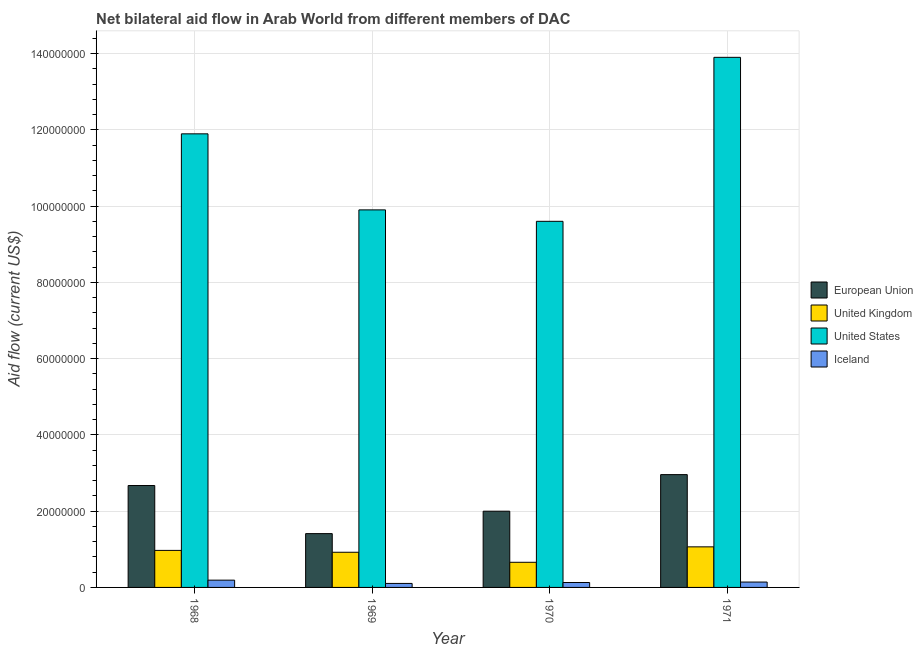How many groups of bars are there?
Provide a short and direct response. 4. Are the number of bars on each tick of the X-axis equal?
Make the answer very short. Yes. How many bars are there on the 2nd tick from the left?
Make the answer very short. 4. How many bars are there on the 1st tick from the right?
Provide a succinct answer. 4. What is the label of the 3rd group of bars from the left?
Your answer should be very brief. 1970. In how many cases, is the number of bars for a given year not equal to the number of legend labels?
Provide a succinct answer. 0. What is the amount of aid given by iceland in 1968?
Give a very brief answer. 1.91e+06. Across all years, what is the maximum amount of aid given by iceland?
Your response must be concise. 1.91e+06. Across all years, what is the minimum amount of aid given by iceland?
Provide a short and direct response. 1.05e+06. In which year was the amount of aid given by eu maximum?
Your answer should be compact. 1971. In which year was the amount of aid given by iceland minimum?
Your answer should be very brief. 1969. What is the total amount of aid given by iceland in the graph?
Provide a succinct answer. 5.66e+06. What is the difference between the amount of aid given by us in 1968 and that in 1970?
Keep it short and to the point. 2.29e+07. What is the difference between the amount of aid given by eu in 1970 and the amount of aid given by uk in 1968?
Keep it short and to the point. -6.73e+06. What is the average amount of aid given by us per year?
Make the answer very short. 1.13e+08. What is the ratio of the amount of aid given by iceland in 1968 to that in 1969?
Ensure brevity in your answer.  1.82. What is the difference between the highest and the second highest amount of aid given by eu?
Provide a succinct answer. 2.86e+06. What is the difference between the highest and the lowest amount of aid given by eu?
Keep it short and to the point. 1.55e+07. In how many years, is the amount of aid given by iceland greater than the average amount of aid given by iceland taken over all years?
Ensure brevity in your answer.  1. What does the 1st bar from the right in 1969 represents?
Keep it short and to the point. Iceland. How many bars are there?
Give a very brief answer. 16. Are all the bars in the graph horizontal?
Offer a very short reply. No. How many years are there in the graph?
Offer a very short reply. 4. What is the difference between two consecutive major ticks on the Y-axis?
Your answer should be very brief. 2.00e+07. Are the values on the major ticks of Y-axis written in scientific E-notation?
Give a very brief answer. No. Does the graph contain grids?
Ensure brevity in your answer.  Yes. Where does the legend appear in the graph?
Provide a succinct answer. Center right. How are the legend labels stacked?
Provide a succinct answer. Vertical. What is the title of the graph?
Provide a short and direct response. Net bilateral aid flow in Arab World from different members of DAC. What is the Aid flow (current US$) of European Union in 1968?
Offer a very short reply. 2.67e+07. What is the Aid flow (current US$) in United Kingdom in 1968?
Make the answer very short. 9.71e+06. What is the Aid flow (current US$) in United States in 1968?
Keep it short and to the point. 1.19e+08. What is the Aid flow (current US$) of Iceland in 1968?
Provide a succinct answer. 1.91e+06. What is the Aid flow (current US$) in European Union in 1969?
Offer a terse response. 1.41e+07. What is the Aid flow (current US$) in United Kingdom in 1969?
Make the answer very short. 9.22e+06. What is the Aid flow (current US$) of United States in 1969?
Keep it short and to the point. 9.90e+07. What is the Aid flow (current US$) of Iceland in 1969?
Your response must be concise. 1.05e+06. What is the Aid flow (current US$) in European Union in 1970?
Provide a succinct answer. 2.00e+07. What is the Aid flow (current US$) of United Kingdom in 1970?
Provide a succinct answer. 6.59e+06. What is the Aid flow (current US$) in United States in 1970?
Ensure brevity in your answer.  9.60e+07. What is the Aid flow (current US$) in Iceland in 1970?
Ensure brevity in your answer.  1.29e+06. What is the Aid flow (current US$) of European Union in 1971?
Your answer should be very brief. 2.96e+07. What is the Aid flow (current US$) of United Kingdom in 1971?
Your answer should be compact. 1.06e+07. What is the Aid flow (current US$) of United States in 1971?
Your answer should be compact. 1.39e+08. What is the Aid flow (current US$) in Iceland in 1971?
Provide a succinct answer. 1.41e+06. Across all years, what is the maximum Aid flow (current US$) of European Union?
Your answer should be very brief. 2.96e+07. Across all years, what is the maximum Aid flow (current US$) in United Kingdom?
Provide a short and direct response. 1.06e+07. Across all years, what is the maximum Aid flow (current US$) of United States?
Your answer should be compact. 1.39e+08. Across all years, what is the maximum Aid flow (current US$) of Iceland?
Ensure brevity in your answer.  1.91e+06. Across all years, what is the minimum Aid flow (current US$) in European Union?
Your answer should be very brief. 1.41e+07. Across all years, what is the minimum Aid flow (current US$) in United Kingdom?
Ensure brevity in your answer.  6.59e+06. Across all years, what is the minimum Aid flow (current US$) of United States?
Offer a terse response. 9.60e+07. Across all years, what is the minimum Aid flow (current US$) in Iceland?
Offer a terse response. 1.05e+06. What is the total Aid flow (current US$) in European Union in the graph?
Give a very brief answer. 9.04e+07. What is the total Aid flow (current US$) in United Kingdom in the graph?
Provide a short and direct response. 3.62e+07. What is the total Aid flow (current US$) of United States in the graph?
Ensure brevity in your answer.  4.53e+08. What is the total Aid flow (current US$) in Iceland in the graph?
Make the answer very short. 5.66e+06. What is the difference between the Aid flow (current US$) in European Union in 1968 and that in 1969?
Your response must be concise. 1.26e+07. What is the difference between the Aid flow (current US$) of United Kingdom in 1968 and that in 1969?
Ensure brevity in your answer.  4.90e+05. What is the difference between the Aid flow (current US$) of United States in 1968 and that in 1969?
Make the answer very short. 1.99e+07. What is the difference between the Aid flow (current US$) in Iceland in 1968 and that in 1969?
Ensure brevity in your answer.  8.60e+05. What is the difference between the Aid flow (current US$) of European Union in 1968 and that in 1970?
Ensure brevity in your answer.  6.73e+06. What is the difference between the Aid flow (current US$) in United Kingdom in 1968 and that in 1970?
Your answer should be very brief. 3.12e+06. What is the difference between the Aid flow (current US$) in United States in 1968 and that in 1970?
Offer a terse response. 2.29e+07. What is the difference between the Aid flow (current US$) in Iceland in 1968 and that in 1970?
Offer a very short reply. 6.20e+05. What is the difference between the Aid flow (current US$) of European Union in 1968 and that in 1971?
Your answer should be compact. -2.86e+06. What is the difference between the Aid flow (current US$) of United Kingdom in 1968 and that in 1971?
Your answer should be compact. -9.30e+05. What is the difference between the Aid flow (current US$) in United States in 1968 and that in 1971?
Give a very brief answer. -2.01e+07. What is the difference between the Aid flow (current US$) of Iceland in 1968 and that in 1971?
Offer a very short reply. 5.00e+05. What is the difference between the Aid flow (current US$) in European Union in 1969 and that in 1970?
Keep it short and to the point. -5.88e+06. What is the difference between the Aid flow (current US$) of United Kingdom in 1969 and that in 1970?
Your response must be concise. 2.63e+06. What is the difference between the Aid flow (current US$) of Iceland in 1969 and that in 1970?
Provide a short and direct response. -2.40e+05. What is the difference between the Aid flow (current US$) in European Union in 1969 and that in 1971?
Offer a terse response. -1.55e+07. What is the difference between the Aid flow (current US$) in United Kingdom in 1969 and that in 1971?
Your answer should be compact. -1.42e+06. What is the difference between the Aid flow (current US$) of United States in 1969 and that in 1971?
Your answer should be very brief. -4.00e+07. What is the difference between the Aid flow (current US$) of Iceland in 1969 and that in 1971?
Make the answer very short. -3.60e+05. What is the difference between the Aid flow (current US$) in European Union in 1970 and that in 1971?
Provide a succinct answer. -9.59e+06. What is the difference between the Aid flow (current US$) in United Kingdom in 1970 and that in 1971?
Give a very brief answer. -4.05e+06. What is the difference between the Aid flow (current US$) of United States in 1970 and that in 1971?
Make the answer very short. -4.30e+07. What is the difference between the Aid flow (current US$) in Iceland in 1970 and that in 1971?
Give a very brief answer. -1.20e+05. What is the difference between the Aid flow (current US$) in European Union in 1968 and the Aid flow (current US$) in United Kingdom in 1969?
Your answer should be compact. 1.75e+07. What is the difference between the Aid flow (current US$) in European Union in 1968 and the Aid flow (current US$) in United States in 1969?
Offer a terse response. -7.23e+07. What is the difference between the Aid flow (current US$) of European Union in 1968 and the Aid flow (current US$) of Iceland in 1969?
Ensure brevity in your answer.  2.57e+07. What is the difference between the Aid flow (current US$) of United Kingdom in 1968 and the Aid flow (current US$) of United States in 1969?
Provide a short and direct response. -8.93e+07. What is the difference between the Aid flow (current US$) of United Kingdom in 1968 and the Aid flow (current US$) of Iceland in 1969?
Provide a short and direct response. 8.66e+06. What is the difference between the Aid flow (current US$) of United States in 1968 and the Aid flow (current US$) of Iceland in 1969?
Your answer should be very brief. 1.18e+08. What is the difference between the Aid flow (current US$) in European Union in 1968 and the Aid flow (current US$) in United Kingdom in 1970?
Offer a terse response. 2.01e+07. What is the difference between the Aid flow (current US$) in European Union in 1968 and the Aid flow (current US$) in United States in 1970?
Offer a terse response. -6.93e+07. What is the difference between the Aid flow (current US$) of European Union in 1968 and the Aid flow (current US$) of Iceland in 1970?
Offer a very short reply. 2.54e+07. What is the difference between the Aid flow (current US$) of United Kingdom in 1968 and the Aid flow (current US$) of United States in 1970?
Your answer should be compact. -8.63e+07. What is the difference between the Aid flow (current US$) of United Kingdom in 1968 and the Aid flow (current US$) of Iceland in 1970?
Your answer should be very brief. 8.42e+06. What is the difference between the Aid flow (current US$) of United States in 1968 and the Aid flow (current US$) of Iceland in 1970?
Your response must be concise. 1.18e+08. What is the difference between the Aid flow (current US$) in European Union in 1968 and the Aid flow (current US$) in United Kingdom in 1971?
Offer a terse response. 1.61e+07. What is the difference between the Aid flow (current US$) in European Union in 1968 and the Aid flow (current US$) in United States in 1971?
Make the answer very short. -1.12e+08. What is the difference between the Aid flow (current US$) in European Union in 1968 and the Aid flow (current US$) in Iceland in 1971?
Your answer should be compact. 2.53e+07. What is the difference between the Aid flow (current US$) in United Kingdom in 1968 and the Aid flow (current US$) in United States in 1971?
Keep it short and to the point. -1.29e+08. What is the difference between the Aid flow (current US$) of United Kingdom in 1968 and the Aid flow (current US$) of Iceland in 1971?
Provide a succinct answer. 8.30e+06. What is the difference between the Aid flow (current US$) of United States in 1968 and the Aid flow (current US$) of Iceland in 1971?
Offer a terse response. 1.18e+08. What is the difference between the Aid flow (current US$) of European Union in 1969 and the Aid flow (current US$) of United Kingdom in 1970?
Ensure brevity in your answer.  7.52e+06. What is the difference between the Aid flow (current US$) of European Union in 1969 and the Aid flow (current US$) of United States in 1970?
Provide a short and direct response. -8.19e+07. What is the difference between the Aid flow (current US$) in European Union in 1969 and the Aid flow (current US$) in Iceland in 1970?
Keep it short and to the point. 1.28e+07. What is the difference between the Aid flow (current US$) in United Kingdom in 1969 and the Aid flow (current US$) in United States in 1970?
Your response must be concise. -8.68e+07. What is the difference between the Aid flow (current US$) in United Kingdom in 1969 and the Aid flow (current US$) in Iceland in 1970?
Make the answer very short. 7.93e+06. What is the difference between the Aid flow (current US$) of United States in 1969 and the Aid flow (current US$) of Iceland in 1970?
Your answer should be very brief. 9.77e+07. What is the difference between the Aid flow (current US$) of European Union in 1969 and the Aid flow (current US$) of United Kingdom in 1971?
Offer a terse response. 3.47e+06. What is the difference between the Aid flow (current US$) of European Union in 1969 and the Aid flow (current US$) of United States in 1971?
Provide a succinct answer. -1.25e+08. What is the difference between the Aid flow (current US$) of European Union in 1969 and the Aid flow (current US$) of Iceland in 1971?
Your response must be concise. 1.27e+07. What is the difference between the Aid flow (current US$) in United Kingdom in 1969 and the Aid flow (current US$) in United States in 1971?
Provide a succinct answer. -1.30e+08. What is the difference between the Aid flow (current US$) in United Kingdom in 1969 and the Aid flow (current US$) in Iceland in 1971?
Offer a very short reply. 7.81e+06. What is the difference between the Aid flow (current US$) in United States in 1969 and the Aid flow (current US$) in Iceland in 1971?
Provide a short and direct response. 9.76e+07. What is the difference between the Aid flow (current US$) in European Union in 1970 and the Aid flow (current US$) in United Kingdom in 1971?
Provide a short and direct response. 9.35e+06. What is the difference between the Aid flow (current US$) of European Union in 1970 and the Aid flow (current US$) of United States in 1971?
Your answer should be compact. -1.19e+08. What is the difference between the Aid flow (current US$) in European Union in 1970 and the Aid flow (current US$) in Iceland in 1971?
Your answer should be very brief. 1.86e+07. What is the difference between the Aid flow (current US$) of United Kingdom in 1970 and the Aid flow (current US$) of United States in 1971?
Your answer should be compact. -1.32e+08. What is the difference between the Aid flow (current US$) of United Kingdom in 1970 and the Aid flow (current US$) of Iceland in 1971?
Make the answer very short. 5.18e+06. What is the difference between the Aid flow (current US$) in United States in 1970 and the Aid flow (current US$) in Iceland in 1971?
Offer a very short reply. 9.46e+07. What is the average Aid flow (current US$) of European Union per year?
Offer a terse response. 2.26e+07. What is the average Aid flow (current US$) of United Kingdom per year?
Ensure brevity in your answer.  9.04e+06. What is the average Aid flow (current US$) in United States per year?
Provide a succinct answer. 1.13e+08. What is the average Aid flow (current US$) of Iceland per year?
Keep it short and to the point. 1.42e+06. In the year 1968, what is the difference between the Aid flow (current US$) in European Union and Aid flow (current US$) in United Kingdom?
Provide a succinct answer. 1.70e+07. In the year 1968, what is the difference between the Aid flow (current US$) in European Union and Aid flow (current US$) in United States?
Keep it short and to the point. -9.22e+07. In the year 1968, what is the difference between the Aid flow (current US$) of European Union and Aid flow (current US$) of Iceland?
Provide a succinct answer. 2.48e+07. In the year 1968, what is the difference between the Aid flow (current US$) in United Kingdom and Aid flow (current US$) in United States?
Give a very brief answer. -1.09e+08. In the year 1968, what is the difference between the Aid flow (current US$) in United Kingdom and Aid flow (current US$) in Iceland?
Provide a succinct answer. 7.80e+06. In the year 1968, what is the difference between the Aid flow (current US$) of United States and Aid flow (current US$) of Iceland?
Your response must be concise. 1.17e+08. In the year 1969, what is the difference between the Aid flow (current US$) in European Union and Aid flow (current US$) in United Kingdom?
Offer a very short reply. 4.89e+06. In the year 1969, what is the difference between the Aid flow (current US$) of European Union and Aid flow (current US$) of United States?
Make the answer very short. -8.49e+07. In the year 1969, what is the difference between the Aid flow (current US$) of European Union and Aid flow (current US$) of Iceland?
Provide a short and direct response. 1.31e+07. In the year 1969, what is the difference between the Aid flow (current US$) of United Kingdom and Aid flow (current US$) of United States?
Your response must be concise. -8.98e+07. In the year 1969, what is the difference between the Aid flow (current US$) in United Kingdom and Aid flow (current US$) in Iceland?
Ensure brevity in your answer.  8.17e+06. In the year 1969, what is the difference between the Aid flow (current US$) of United States and Aid flow (current US$) of Iceland?
Offer a very short reply. 9.80e+07. In the year 1970, what is the difference between the Aid flow (current US$) in European Union and Aid flow (current US$) in United Kingdom?
Ensure brevity in your answer.  1.34e+07. In the year 1970, what is the difference between the Aid flow (current US$) in European Union and Aid flow (current US$) in United States?
Your answer should be compact. -7.60e+07. In the year 1970, what is the difference between the Aid flow (current US$) in European Union and Aid flow (current US$) in Iceland?
Make the answer very short. 1.87e+07. In the year 1970, what is the difference between the Aid flow (current US$) in United Kingdom and Aid flow (current US$) in United States?
Offer a very short reply. -8.94e+07. In the year 1970, what is the difference between the Aid flow (current US$) of United Kingdom and Aid flow (current US$) of Iceland?
Keep it short and to the point. 5.30e+06. In the year 1970, what is the difference between the Aid flow (current US$) in United States and Aid flow (current US$) in Iceland?
Provide a succinct answer. 9.47e+07. In the year 1971, what is the difference between the Aid flow (current US$) in European Union and Aid flow (current US$) in United Kingdom?
Make the answer very short. 1.89e+07. In the year 1971, what is the difference between the Aid flow (current US$) of European Union and Aid flow (current US$) of United States?
Your answer should be compact. -1.09e+08. In the year 1971, what is the difference between the Aid flow (current US$) of European Union and Aid flow (current US$) of Iceland?
Keep it short and to the point. 2.82e+07. In the year 1971, what is the difference between the Aid flow (current US$) of United Kingdom and Aid flow (current US$) of United States?
Make the answer very short. -1.28e+08. In the year 1971, what is the difference between the Aid flow (current US$) of United Kingdom and Aid flow (current US$) of Iceland?
Your answer should be compact. 9.23e+06. In the year 1971, what is the difference between the Aid flow (current US$) in United States and Aid flow (current US$) in Iceland?
Make the answer very short. 1.38e+08. What is the ratio of the Aid flow (current US$) of European Union in 1968 to that in 1969?
Offer a terse response. 1.89. What is the ratio of the Aid flow (current US$) in United Kingdom in 1968 to that in 1969?
Provide a short and direct response. 1.05. What is the ratio of the Aid flow (current US$) in United States in 1968 to that in 1969?
Your answer should be very brief. 1.2. What is the ratio of the Aid flow (current US$) of Iceland in 1968 to that in 1969?
Ensure brevity in your answer.  1.82. What is the ratio of the Aid flow (current US$) of European Union in 1968 to that in 1970?
Ensure brevity in your answer.  1.34. What is the ratio of the Aid flow (current US$) in United Kingdom in 1968 to that in 1970?
Offer a very short reply. 1.47. What is the ratio of the Aid flow (current US$) of United States in 1968 to that in 1970?
Keep it short and to the point. 1.24. What is the ratio of the Aid flow (current US$) of Iceland in 1968 to that in 1970?
Give a very brief answer. 1.48. What is the ratio of the Aid flow (current US$) of European Union in 1968 to that in 1971?
Offer a very short reply. 0.9. What is the ratio of the Aid flow (current US$) of United Kingdom in 1968 to that in 1971?
Your answer should be very brief. 0.91. What is the ratio of the Aid flow (current US$) of United States in 1968 to that in 1971?
Give a very brief answer. 0.86. What is the ratio of the Aid flow (current US$) in Iceland in 1968 to that in 1971?
Ensure brevity in your answer.  1.35. What is the ratio of the Aid flow (current US$) in European Union in 1969 to that in 1970?
Provide a short and direct response. 0.71. What is the ratio of the Aid flow (current US$) of United Kingdom in 1969 to that in 1970?
Make the answer very short. 1.4. What is the ratio of the Aid flow (current US$) of United States in 1969 to that in 1970?
Offer a terse response. 1.03. What is the ratio of the Aid flow (current US$) in Iceland in 1969 to that in 1970?
Your response must be concise. 0.81. What is the ratio of the Aid flow (current US$) in European Union in 1969 to that in 1971?
Provide a succinct answer. 0.48. What is the ratio of the Aid flow (current US$) of United Kingdom in 1969 to that in 1971?
Offer a terse response. 0.87. What is the ratio of the Aid flow (current US$) in United States in 1969 to that in 1971?
Your answer should be very brief. 0.71. What is the ratio of the Aid flow (current US$) of Iceland in 1969 to that in 1971?
Ensure brevity in your answer.  0.74. What is the ratio of the Aid flow (current US$) in European Union in 1970 to that in 1971?
Provide a short and direct response. 0.68. What is the ratio of the Aid flow (current US$) of United Kingdom in 1970 to that in 1971?
Keep it short and to the point. 0.62. What is the ratio of the Aid flow (current US$) of United States in 1970 to that in 1971?
Your response must be concise. 0.69. What is the ratio of the Aid flow (current US$) of Iceland in 1970 to that in 1971?
Ensure brevity in your answer.  0.91. What is the difference between the highest and the second highest Aid flow (current US$) in European Union?
Give a very brief answer. 2.86e+06. What is the difference between the highest and the second highest Aid flow (current US$) of United Kingdom?
Make the answer very short. 9.30e+05. What is the difference between the highest and the second highest Aid flow (current US$) of United States?
Your answer should be compact. 2.01e+07. What is the difference between the highest and the second highest Aid flow (current US$) in Iceland?
Your response must be concise. 5.00e+05. What is the difference between the highest and the lowest Aid flow (current US$) in European Union?
Provide a succinct answer. 1.55e+07. What is the difference between the highest and the lowest Aid flow (current US$) in United Kingdom?
Provide a short and direct response. 4.05e+06. What is the difference between the highest and the lowest Aid flow (current US$) of United States?
Provide a short and direct response. 4.30e+07. What is the difference between the highest and the lowest Aid flow (current US$) of Iceland?
Provide a succinct answer. 8.60e+05. 